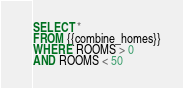<code> <loc_0><loc_0><loc_500><loc_500><_SQL_>SELECT *
FROM {{combine_homes}}
WHERE ROOMS > 0
AND ROOMS < 50</code> 